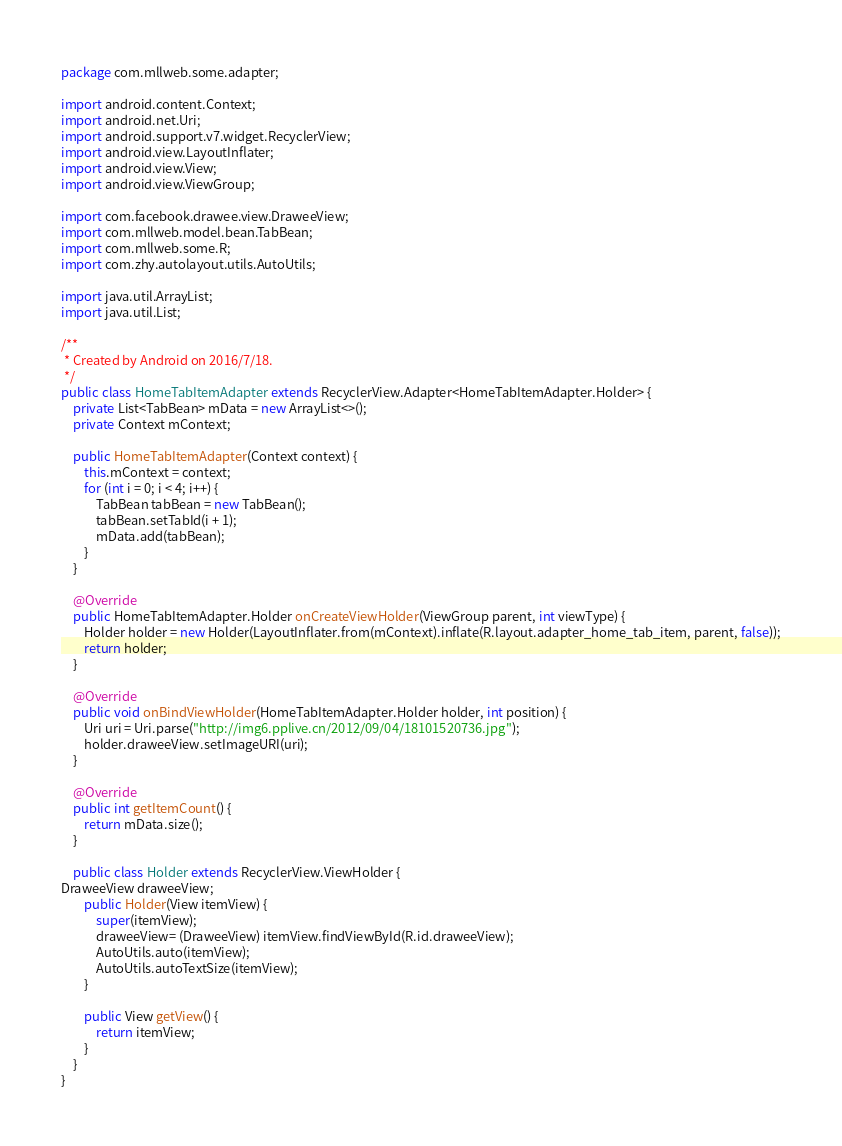Convert code to text. <code><loc_0><loc_0><loc_500><loc_500><_Java_>package com.mllweb.some.adapter;

import android.content.Context;
import android.net.Uri;
import android.support.v7.widget.RecyclerView;
import android.view.LayoutInflater;
import android.view.View;
import android.view.ViewGroup;

import com.facebook.drawee.view.DraweeView;
import com.mllweb.model.bean.TabBean;
import com.mllweb.some.R;
import com.zhy.autolayout.utils.AutoUtils;

import java.util.ArrayList;
import java.util.List;

/**
 * Created by Android on 2016/7/18.
 */
public class HomeTabItemAdapter extends RecyclerView.Adapter<HomeTabItemAdapter.Holder> {
    private List<TabBean> mData = new ArrayList<>();
    private Context mContext;

    public HomeTabItemAdapter(Context context) {
        this.mContext = context;
        for (int i = 0; i < 4; i++) {
            TabBean tabBean = new TabBean();
            tabBean.setTabId(i + 1);
            mData.add(tabBean);
        }
    }

    @Override
    public HomeTabItemAdapter.Holder onCreateViewHolder(ViewGroup parent, int viewType) {
        Holder holder = new Holder(LayoutInflater.from(mContext).inflate(R.layout.adapter_home_tab_item, parent, false));
        return holder;
    }

    @Override
    public void onBindViewHolder(HomeTabItemAdapter.Holder holder, int position) {
        Uri uri = Uri.parse("http://img6.pplive.cn/2012/09/04/18101520736.jpg");
        holder.draweeView.setImageURI(uri);
    }

    @Override
    public int getItemCount() {
        return mData.size();
    }

    public class Holder extends RecyclerView.ViewHolder {
DraweeView draweeView;
        public Holder(View itemView) {
            super(itemView);
            draweeView= (DraweeView) itemView.findViewById(R.id.draweeView);
            AutoUtils.auto(itemView);
            AutoUtils.autoTextSize(itemView);
        }

        public View getView() {
            return itemView;
        }
    }
}
</code> 